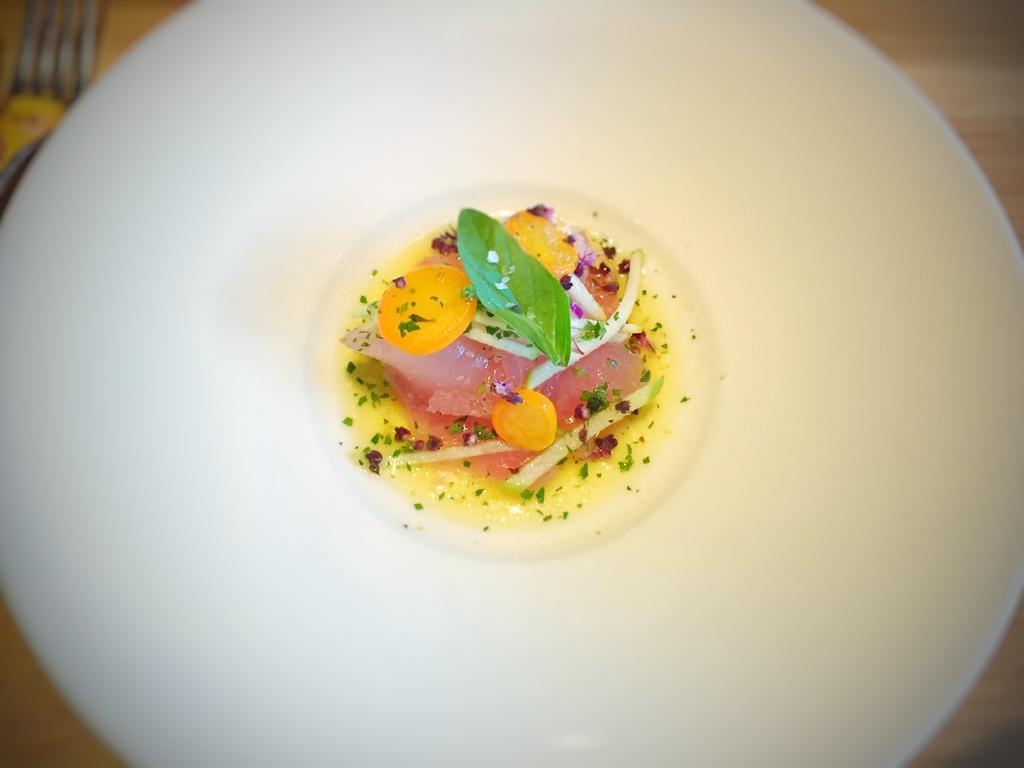Please provide a concise description of this image. This is the image of a plate in which there is some food item. 